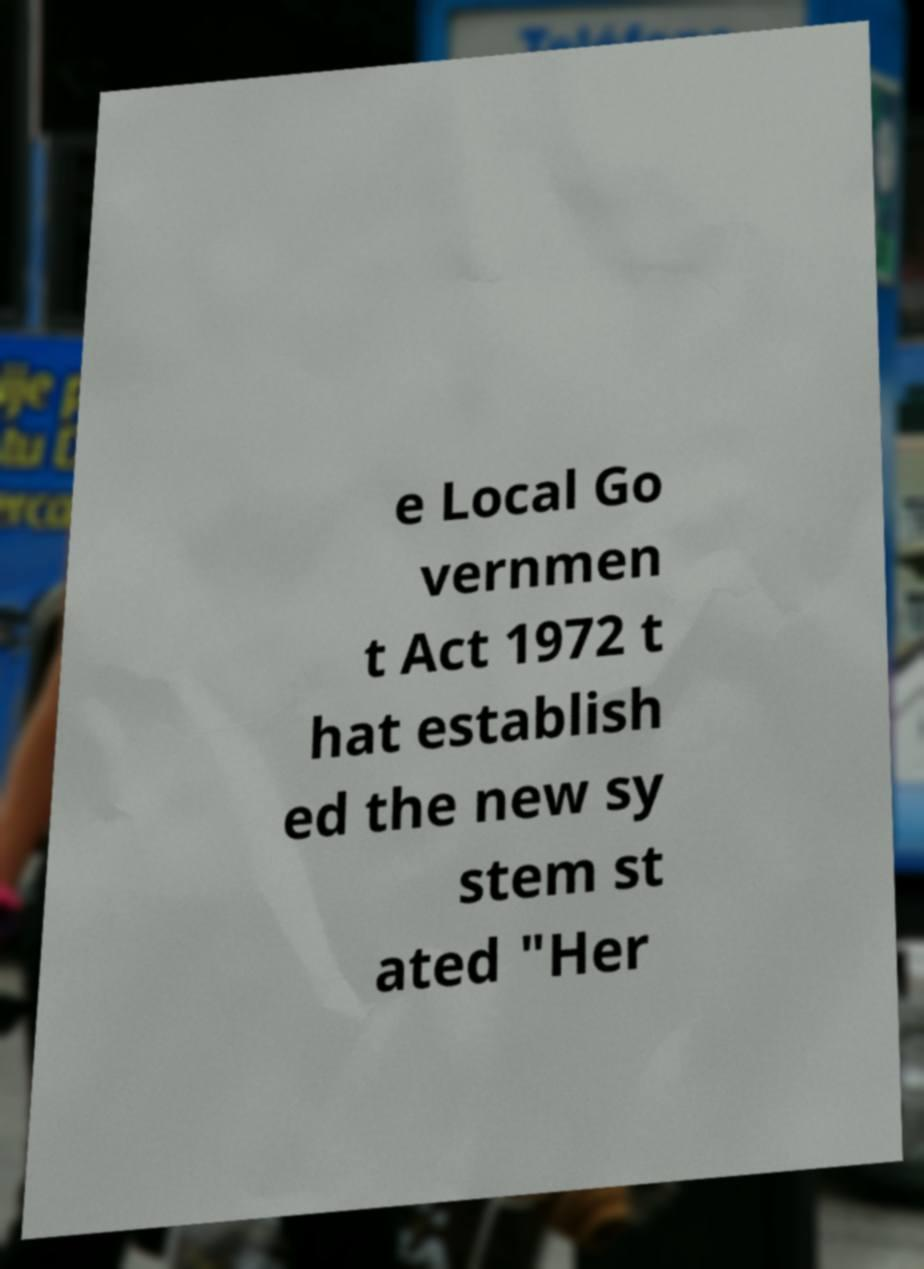Please read and relay the text visible in this image. What does it say? e Local Go vernmen t Act 1972 t hat establish ed the new sy stem st ated "Her 